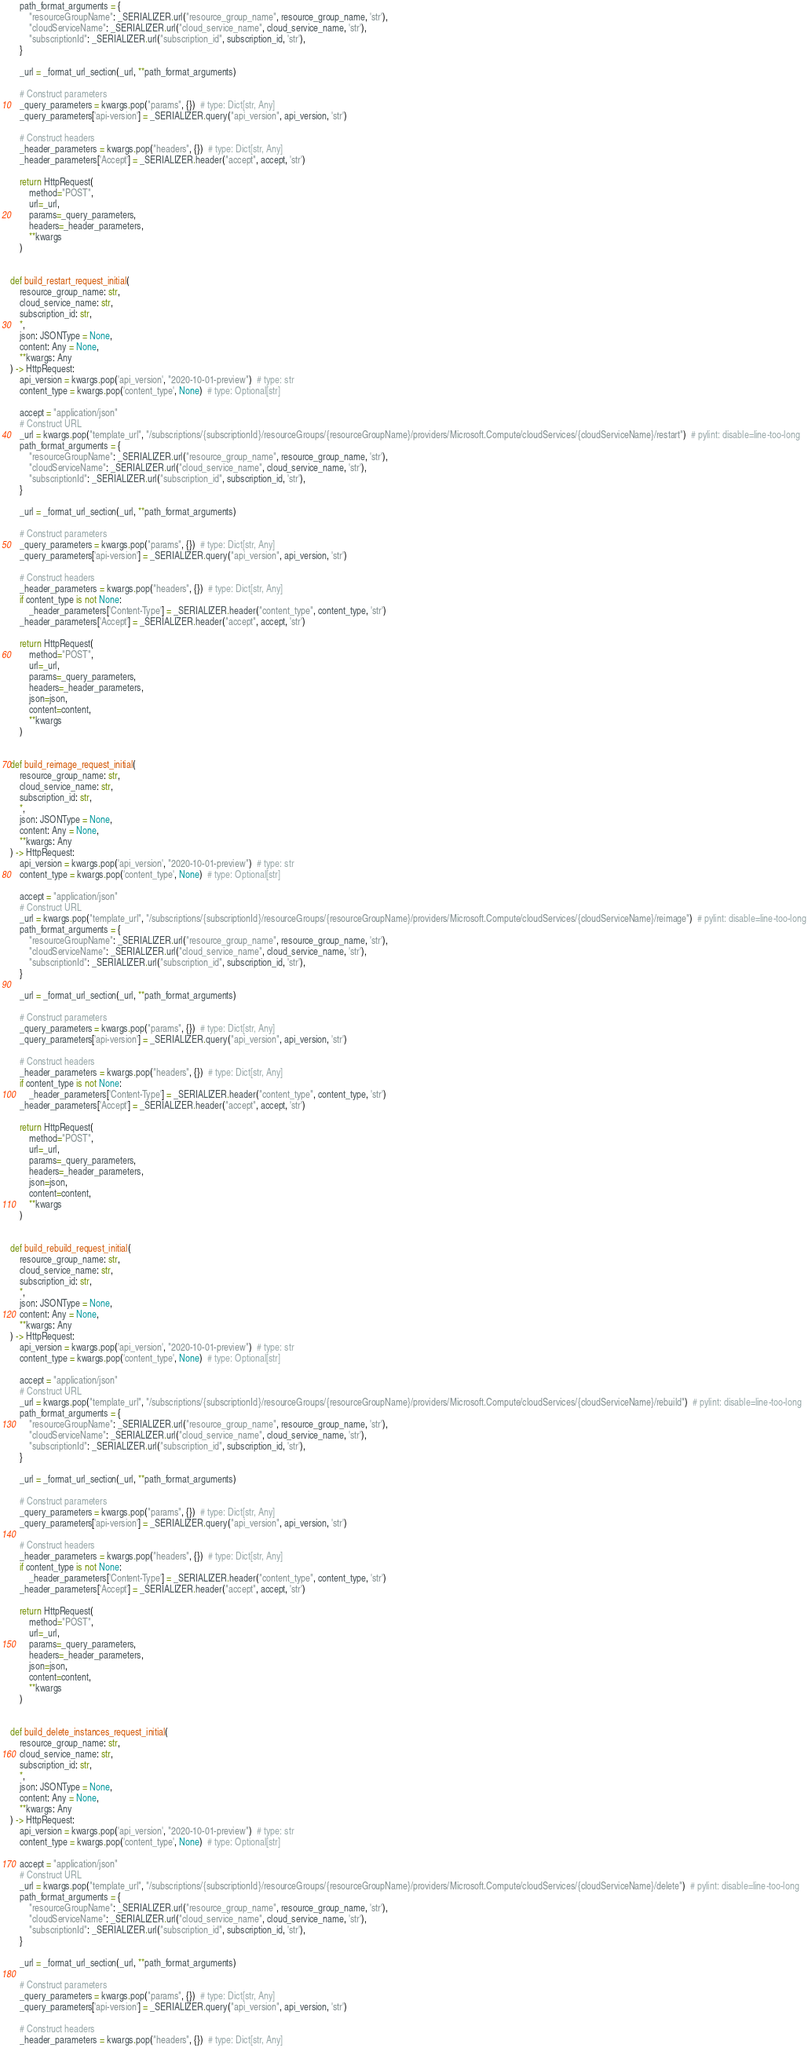<code> <loc_0><loc_0><loc_500><loc_500><_Python_>    path_format_arguments = {
        "resourceGroupName": _SERIALIZER.url("resource_group_name", resource_group_name, 'str'),
        "cloudServiceName": _SERIALIZER.url("cloud_service_name", cloud_service_name, 'str'),
        "subscriptionId": _SERIALIZER.url("subscription_id", subscription_id, 'str'),
    }

    _url = _format_url_section(_url, **path_format_arguments)

    # Construct parameters
    _query_parameters = kwargs.pop("params", {})  # type: Dict[str, Any]
    _query_parameters['api-version'] = _SERIALIZER.query("api_version", api_version, 'str')

    # Construct headers
    _header_parameters = kwargs.pop("headers", {})  # type: Dict[str, Any]
    _header_parameters['Accept'] = _SERIALIZER.header("accept", accept, 'str')

    return HttpRequest(
        method="POST",
        url=_url,
        params=_query_parameters,
        headers=_header_parameters,
        **kwargs
    )


def build_restart_request_initial(
    resource_group_name: str,
    cloud_service_name: str,
    subscription_id: str,
    *,
    json: JSONType = None,
    content: Any = None,
    **kwargs: Any
) -> HttpRequest:
    api_version = kwargs.pop('api_version', "2020-10-01-preview")  # type: str
    content_type = kwargs.pop('content_type', None)  # type: Optional[str]

    accept = "application/json"
    # Construct URL
    _url = kwargs.pop("template_url", "/subscriptions/{subscriptionId}/resourceGroups/{resourceGroupName}/providers/Microsoft.Compute/cloudServices/{cloudServiceName}/restart")  # pylint: disable=line-too-long
    path_format_arguments = {
        "resourceGroupName": _SERIALIZER.url("resource_group_name", resource_group_name, 'str'),
        "cloudServiceName": _SERIALIZER.url("cloud_service_name", cloud_service_name, 'str'),
        "subscriptionId": _SERIALIZER.url("subscription_id", subscription_id, 'str'),
    }

    _url = _format_url_section(_url, **path_format_arguments)

    # Construct parameters
    _query_parameters = kwargs.pop("params", {})  # type: Dict[str, Any]
    _query_parameters['api-version'] = _SERIALIZER.query("api_version", api_version, 'str')

    # Construct headers
    _header_parameters = kwargs.pop("headers", {})  # type: Dict[str, Any]
    if content_type is not None:
        _header_parameters['Content-Type'] = _SERIALIZER.header("content_type", content_type, 'str')
    _header_parameters['Accept'] = _SERIALIZER.header("accept", accept, 'str')

    return HttpRequest(
        method="POST",
        url=_url,
        params=_query_parameters,
        headers=_header_parameters,
        json=json,
        content=content,
        **kwargs
    )


def build_reimage_request_initial(
    resource_group_name: str,
    cloud_service_name: str,
    subscription_id: str,
    *,
    json: JSONType = None,
    content: Any = None,
    **kwargs: Any
) -> HttpRequest:
    api_version = kwargs.pop('api_version', "2020-10-01-preview")  # type: str
    content_type = kwargs.pop('content_type', None)  # type: Optional[str]

    accept = "application/json"
    # Construct URL
    _url = kwargs.pop("template_url", "/subscriptions/{subscriptionId}/resourceGroups/{resourceGroupName}/providers/Microsoft.Compute/cloudServices/{cloudServiceName}/reimage")  # pylint: disable=line-too-long
    path_format_arguments = {
        "resourceGroupName": _SERIALIZER.url("resource_group_name", resource_group_name, 'str'),
        "cloudServiceName": _SERIALIZER.url("cloud_service_name", cloud_service_name, 'str'),
        "subscriptionId": _SERIALIZER.url("subscription_id", subscription_id, 'str'),
    }

    _url = _format_url_section(_url, **path_format_arguments)

    # Construct parameters
    _query_parameters = kwargs.pop("params", {})  # type: Dict[str, Any]
    _query_parameters['api-version'] = _SERIALIZER.query("api_version", api_version, 'str')

    # Construct headers
    _header_parameters = kwargs.pop("headers", {})  # type: Dict[str, Any]
    if content_type is not None:
        _header_parameters['Content-Type'] = _SERIALIZER.header("content_type", content_type, 'str')
    _header_parameters['Accept'] = _SERIALIZER.header("accept", accept, 'str')

    return HttpRequest(
        method="POST",
        url=_url,
        params=_query_parameters,
        headers=_header_parameters,
        json=json,
        content=content,
        **kwargs
    )


def build_rebuild_request_initial(
    resource_group_name: str,
    cloud_service_name: str,
    subscription_id: str,
    *,
    json: JSONType = None,
    content: Any = None,
    **kwargs: Any
) -> HttpRequest:
    api_version = kwargs.pop('api_version', "2020-10-01-preview")  # type: str
    content_type = kwargs.pop('content_type', None)  # type: Optional[str]

    accept = "application/json"
    # Construct URL
    _url = kwargs.pop("template_url", "/subscriptions/{subscriptionId}/resourceGroups/{resourceGroupName}/providers/Microsoft.Compute/cloudServices/{cloudServiceName}/rebuild")  # pylint: disable=line-too-long
    path_format_arguments = {
        "resourceGroupName": _SERIALIZER.url("resource_group_name", resource_group_name, 'str'),
        "cloudServiceName": _SERIALIZER.url("cloud_service_name", cloud_service_name, 'str'),
        "subscriptionId": _SERIALIZER.url("subscription_id", subscription_id, 'str'),
    }

    _url = _format_url_section(_url, **path_format_arguments)

    # Construct parameters
    _query_parameters = kwargs.pop("params", {})  # type: Dict[str, Any]
    _query_parameters['api-version'] = _SERIALIZER.query("api_version", api_version, 'str')

    # Construct headers
    _header_parameters = kwargs.pop("headers", {})  # type: Dict[str, Any]
    if content_type is not None:
        _header_parameters['Content-Type'] = _SERIALIZER.header("content_type", content_type, 'str')
    _header_parameters['Accept'] = _SERIALIZER.header("accept", accept, 'str')

    return HttpRequest(
        method="POST",
        url=_url,
        params=_query_parameters,
        headers=_header_parameters,
        json=json,
        content=content,
        **kwargs
    )


def build_delete_instances_request_initial(
    resource_group_name: str,
    cloud_service_name: str,
    subscription_id: str,
    *,
    json: JSONType = None,
    content: Any = None,
    **kwargs: Any
) -> HttpRequest:
    api_version = kwargs.pop('api_version', "2020-10-01-preview")  # type: str
    content_type = kwargs.pop('content_type', None)  # type: Optional[str]

    accept = "application/json"
    # Construct URL
    _url = kwargs.pop("template_url", "/subscriptions/{subscriptionId}/resourceGroups/{resourceGroupName}/providers/Microsoft.Compute/cloudServices/{cloudServiceName}/delete")  # pylint: disable=line-too-long
    path_format_arguments = {
        "resourceGroupName": _SERIALIZER.url("resource_group_name", resource_group_name, 'str'),
        "cloudServiceName": _SERIALIZER.url("cloud_service_name", cloud_service_name, 'str'),
        "subscriptionId": _SERIALIZER.url("subscription_id", subscription_id, 'str'),
    }

    _url = _format_url_section(_url, **path_format_arguments)

    # Construct parameters
    _query_parameters = kwargs.pop("params", {})  # type: Dict[str, Any]
    _query_parameters['api-version'] = _SERIALIZER.query("api_version", api_version, 'str')

    # Construct headers
    _header_parameters = kwargs.pop("headers", {})  # type: Dict[str, Any]</code> 